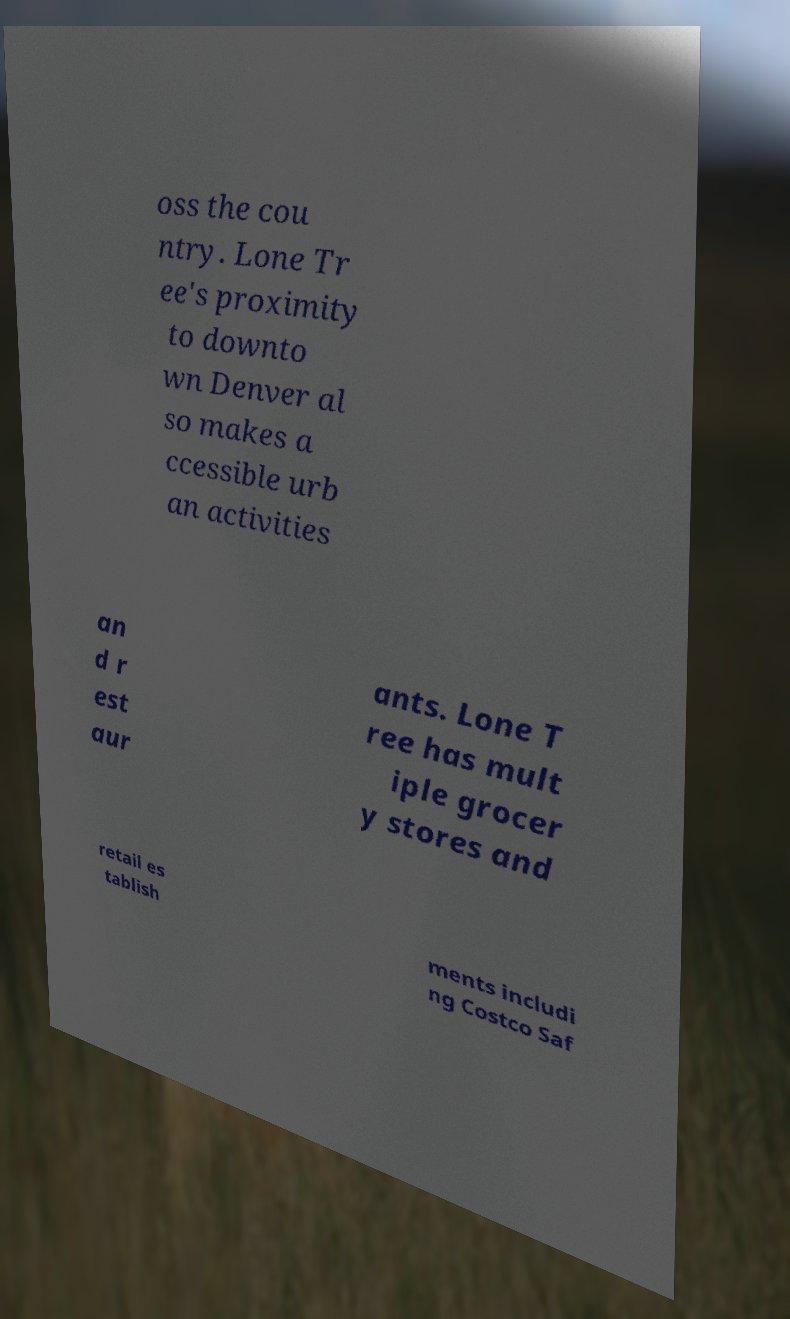Could you extract and type out the text from this image? oss the cou ntry. Lone Tr ee's proximity to downto wn Denver al so makes a ccessible urb an activities an d r est aur ants. Lone T ree has mult iple grocer y stores and retail es tablish ments includi ng Costco Saf 